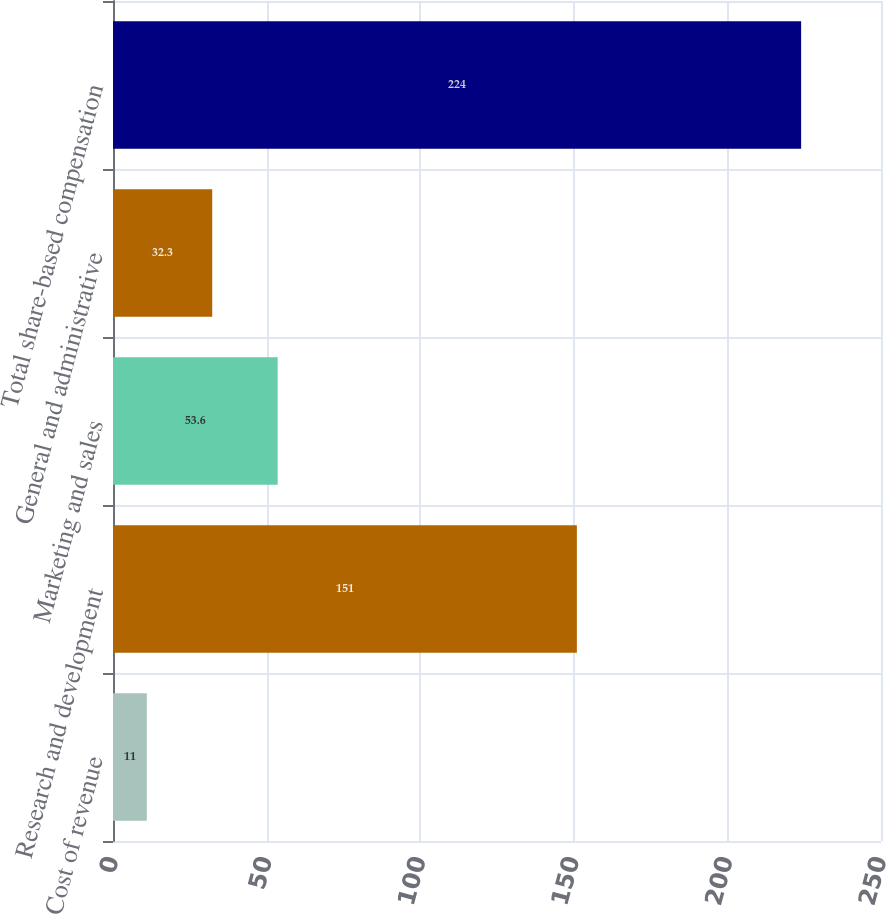Convert chart. <chart><loc_0><loc_0><loc_500><loc_500><bar_chart><fcel>Cost of revenue<fcel>Research and development<fcel>Marketing and sales<fcel>General and administrative<fcel>Total share-based compensation<nl><fcel>11<fcel>151<fcel>53.6<fcel>32.3<fcel>224<nl></chart> 